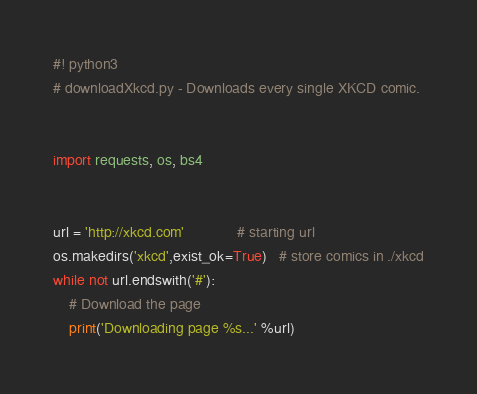Convert code to text. <code><loc_0><loc_0><loc_500><loc_500><_Python_>#! python3
# downloadXkcd.py - Downloads every single XKCD comic.


import requests, os, bs4


url = 'http://xkcd.com'             # starting url
os.makedirs('xkcd',exist_ok=True)   # store comics in ./xkcd
while not url.endswith('#'):
    # Download the page
    print('Downloading page %s...' %url)</code> 